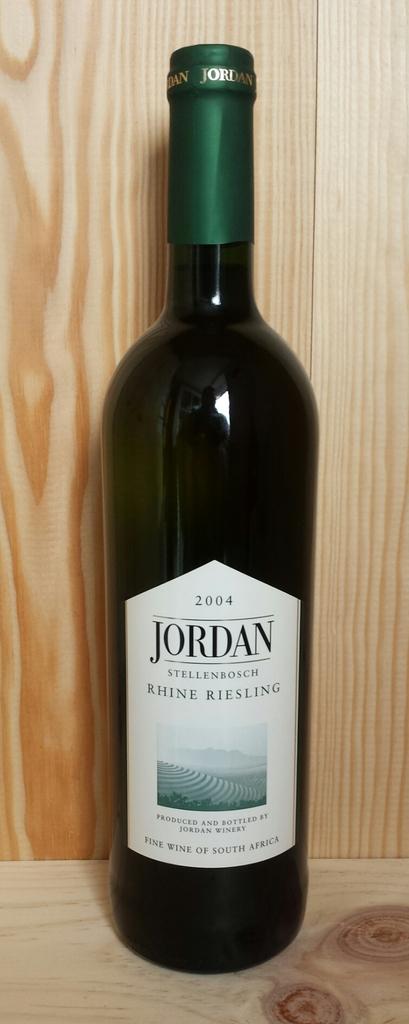Where is jordan made at?
Your answer should be very brief. South africa. What year is the bottle?
Offer a terse response. 2004. 